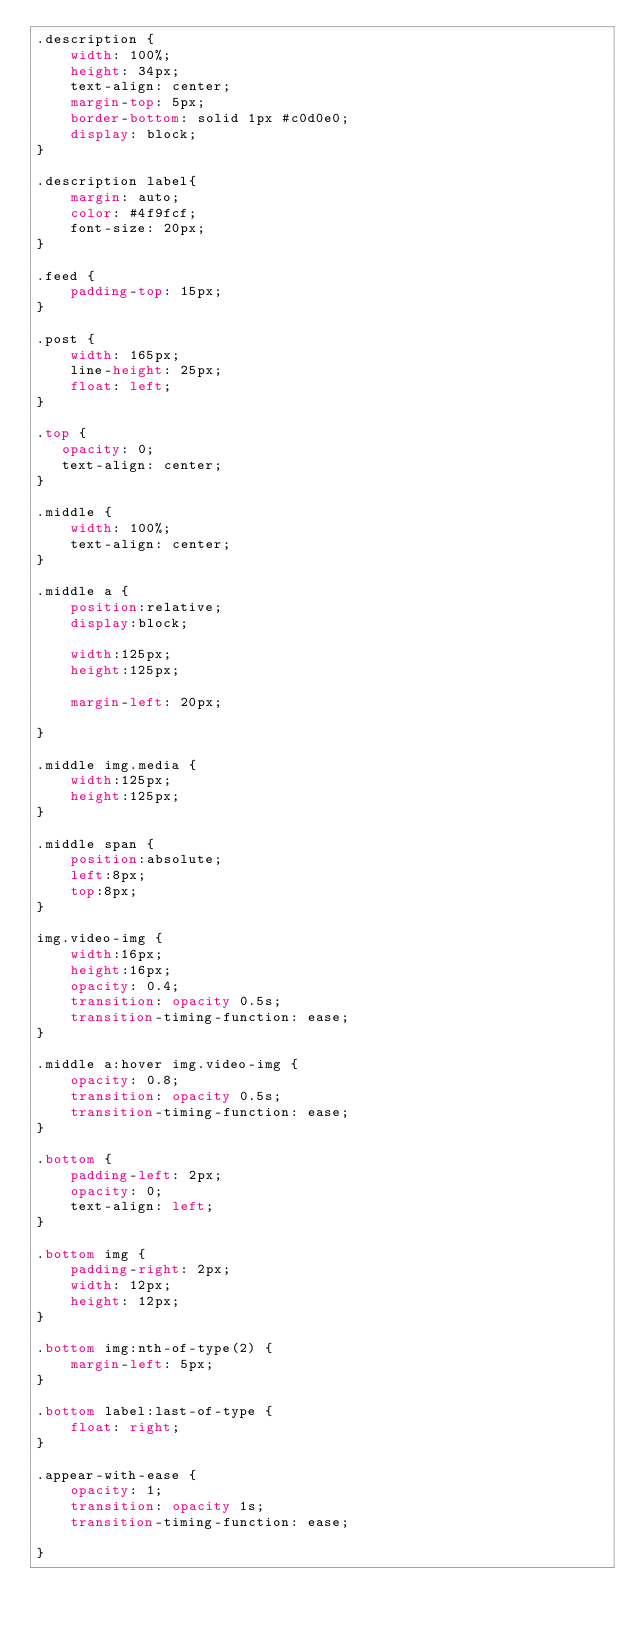<code> <loc_0><loc_0><loc_500><loc_500><_CSS_>.description {
    width: 100%;
    height: 34px;
    text-align: center;
    margin-top: 5px;
    border-bottom: solid 1px #c0d0e0;
    display: block;
}

.description label{
    margin: auto;
    color: #4f9fcf;
    font-size: 20px;
}

.feed {
    padding-top: 15px;
}

.post {
    width: 165px;
    line-height: 25px;
    float: left;
}

.top {
   opacity: 0;
   text-align: center;
}

.middle {
    width: 100%;
    text-align: center;
}

.middle a {
    position:relative;
    display:block;
    
    width:125px;
    height:125px;
    
    margin-left: 20px;

}

.middle img.media {
    width:125px;
    height:125px;
}

.middle span {
    position:absolute;
    left:8px;
    top:8px;
}

img.video-img {
    width:16px;
    height:16px;
    opacity: 0.4;
    transition: opacity 0.5s;
    transition-timing-function: ease;
}

.middle a:hover img.video-img {
    opacity: 0.8;
    transition: opacity 0.5s;
    transition-timing-function: ease;
}

.bottom {
    padding-left: 2px;
    opacity: 0;
    text-align: left;
}

.bottom img {
    padding-right: 2px;
    width: 12px;
    height: 12px;
}

.bottom img:nth-of-type(2) {
    margin-left: 5px;
}

.bottom label:last-of-type {
    float: right;
}

.appear-with-ease {
    opacity: 1;
    transition: opacity 1s;
    transition-timing-function: ease;
  
}</code> 